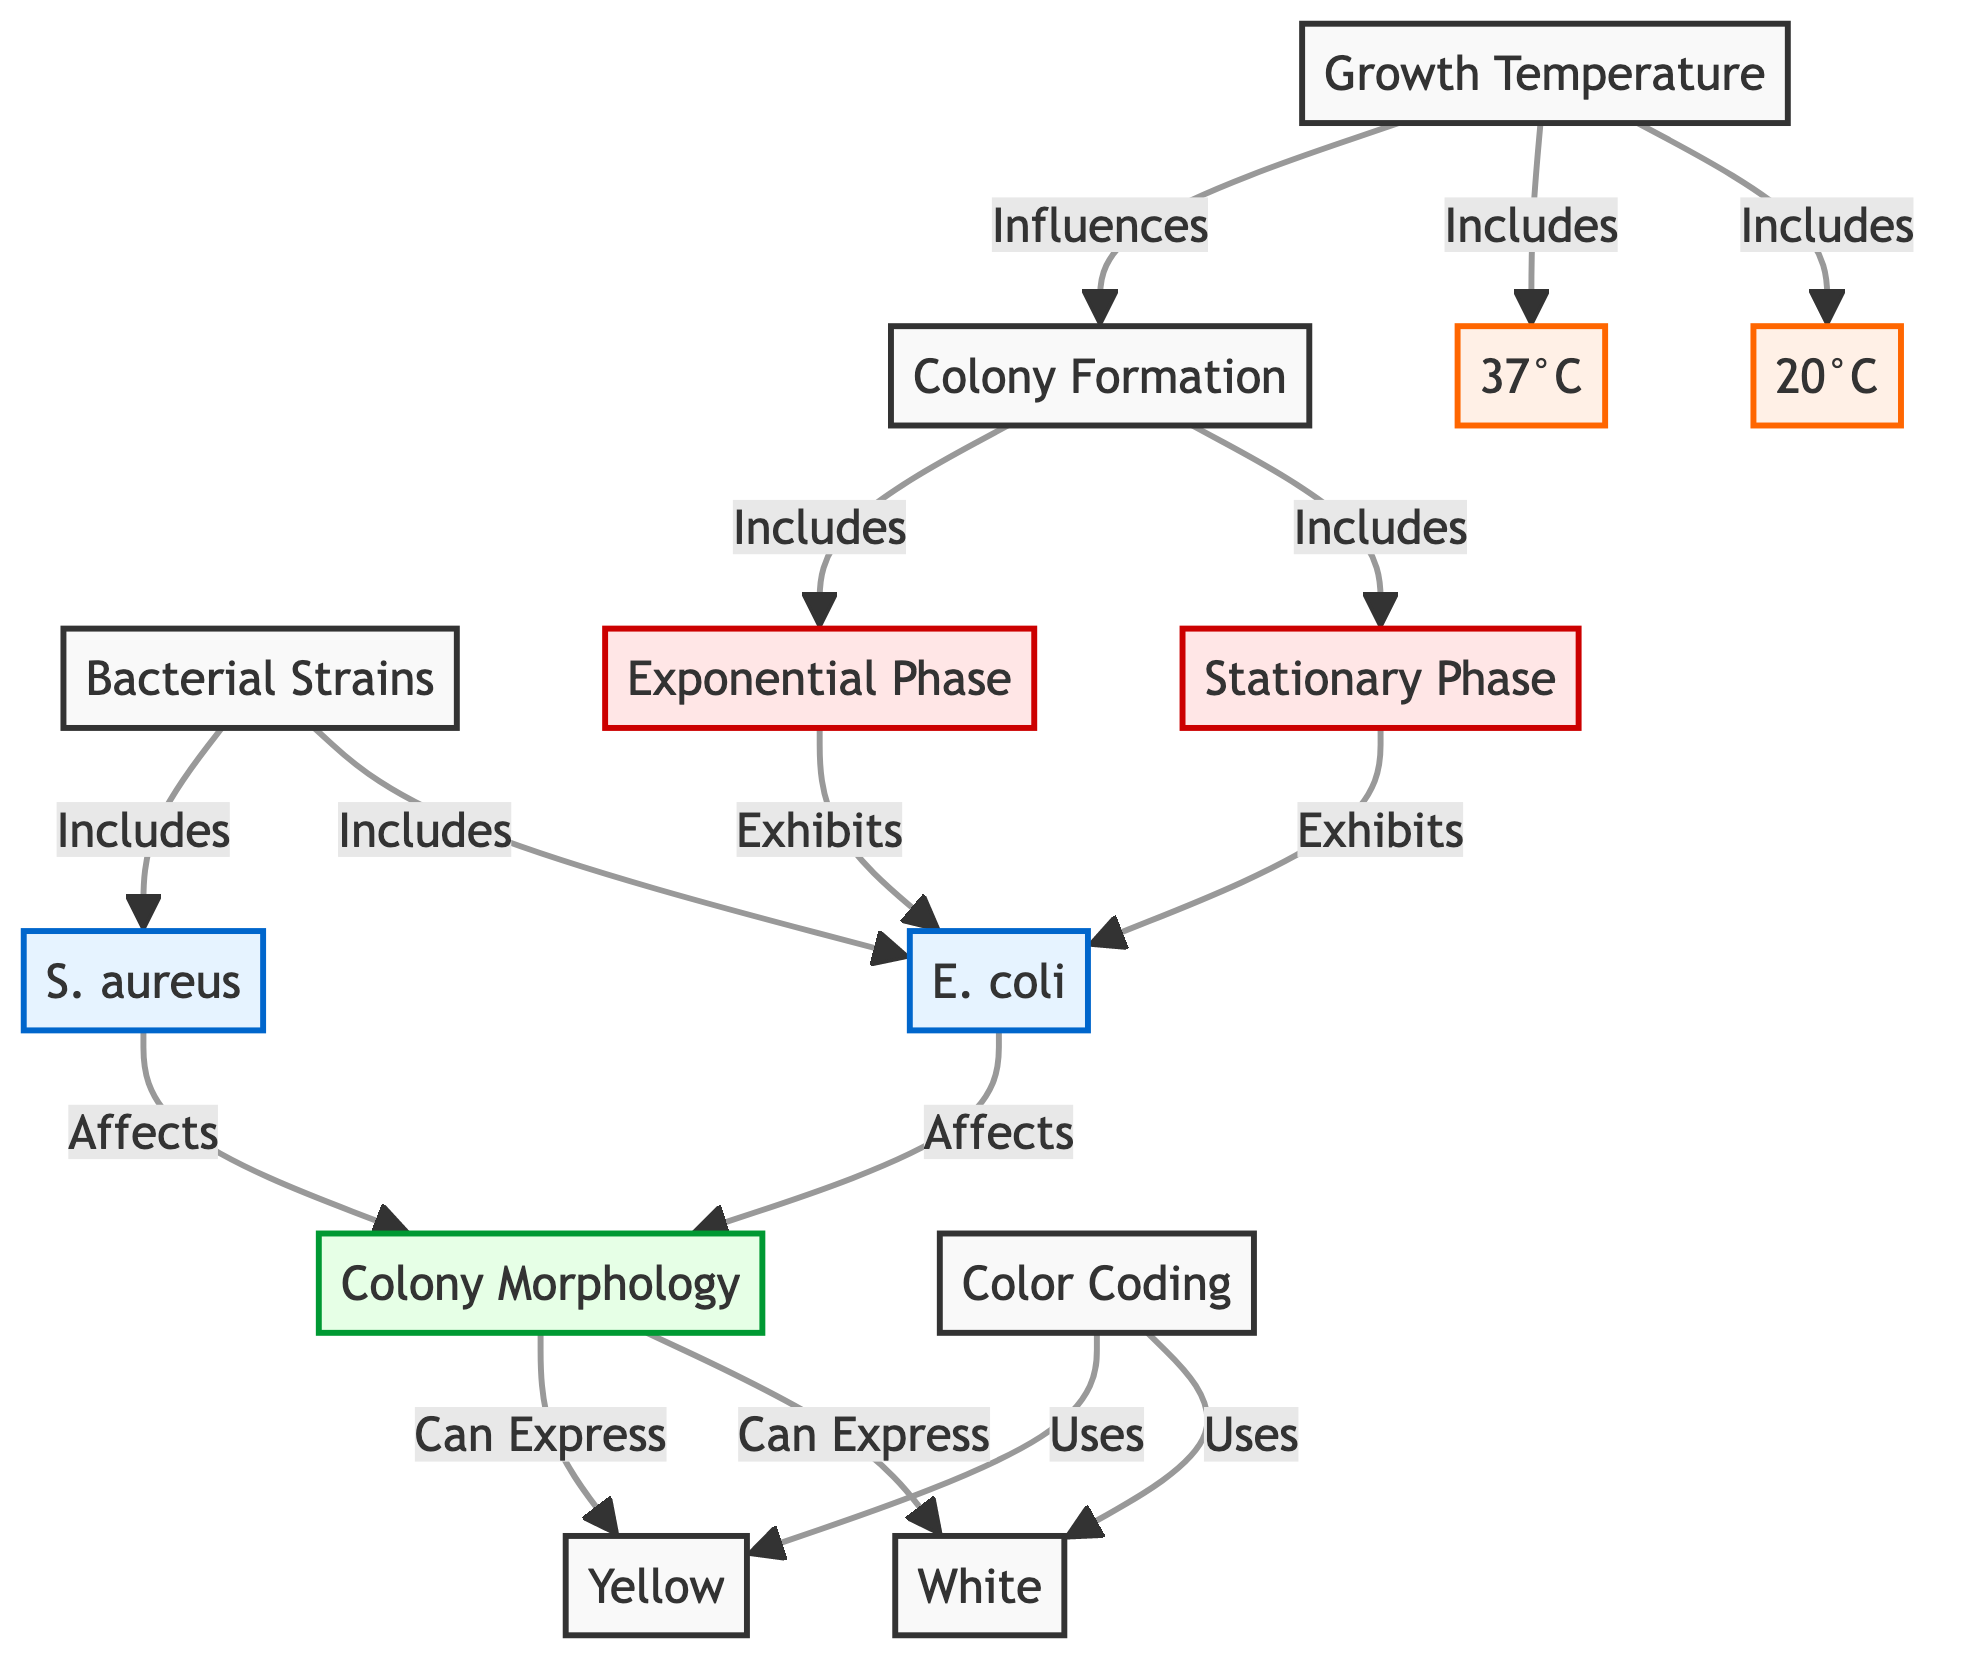What are the two bacterial strains mentioned in the diagram? The diagram lists two bacterial strains: E. coli and S. aureus. I can find these directly under the Bacterial Strains node.
Answer: E. coli and S. aureus How many growth temperature conditions are represented in the diagram? The diagram has one node for Growth Temperature, which includes two specific temperatures: 20°C and 37°C. Thus, there are two conditions represented.
Answer: 2 What color can the colony morphology potentially express? The diagram indicates that colony morphology can express two colors: White and Yellow. These color codes are indicated directly under the Colony Morphology node.
Answer: White and Yellow In which phase does E. coli exhibit during colony formation? The diagram connects E. coli under the Colony Formation node, and it specifies that both the Stationary Phase and Exponential Phase exhibit E. coli. This implies that E. coli is present in both phases.
Answer: Stationary Phase and Exponential Phase How does growth temperature influence colony formation? In the diagram, there is a direct connection from Growth Temperature to Colony Formation. This indicates that the temperature conditions indeed affect how bacterial colonies develop.
Answer: Influences What is the relationship between E. coli and colony morphology? According to the diagram, E. coli affects the colony morphology, showing a direct connection that suggests E. coli can influence how the colonies appear.
Answer: Affects Which bacterial strain is included in the diagram that is known for causing skin infections? The diagram lists S. aureus under bacterial strains, which is commonly known for causing skin infections. This identification is based on the classification under Bacterial Strains.
Answer: S. aureus What phase is exhibited during colony formation that supports rapid growth? The diagram specifically mentions the Exponential Phase under the Colony Formation node, indicating that this phase is characterized by rapid growth.
Answer: Exponential Phase What color is used for the color coding of the bacteria in the diagram? The color coding used in the diagram incorporates White and Yellow, detailing the colors associated with the colony morphology.
Answer: White and Yellow 